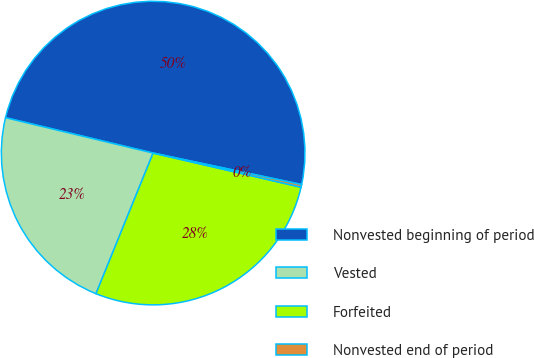Convert chart to OTSL. <chart><loc_0><loc_0><loc_500><loc_500><pie_chart><fcel>Nonvested beginning of period<fcel>Vested<fcel>Forfeited<fcel>Nonvested end of period<nl><fcel>49.58%<fcel>22.6%<fcel>27.53%<fcel>0.29%<nl></chart> 